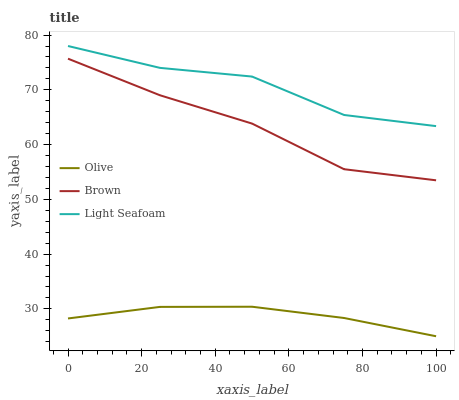Does Olive have the minimum area under the curve?
Answer yes or no. Yes. Does Light Seafoam have the maximum area under the curve?
Answer yes or no. Yes. Does Brown have the minimum area under the curve?
Answer yes or no. No. Does Brown have the maximum area under the curve?
Answer yes or no. No. Is Olive the smoothest?
Answer yes or no. Yes. Is Light Seafoam the roughest?
Answer yes or no. Yes. Is Brown the smoothest?
Answer yes or no. No. Is Brown the roughest?
Answer yes or no. No. Does Olive have the lowest value?
Answer yes or no. Yes. Does Brown have the lowest value?
Answer yes or no. No. Does Light Seafoam have the highest value?
Answer yes or no. Yes. Does Brown have the highest value?
Answer yes or no. No. Is Olive less than Brown?
Answer yes or no. Yes. Is Brown greater than Olive?
Answer yes or no. Yes. Does Olive intersect Brown?
Answer yes or no. No. 